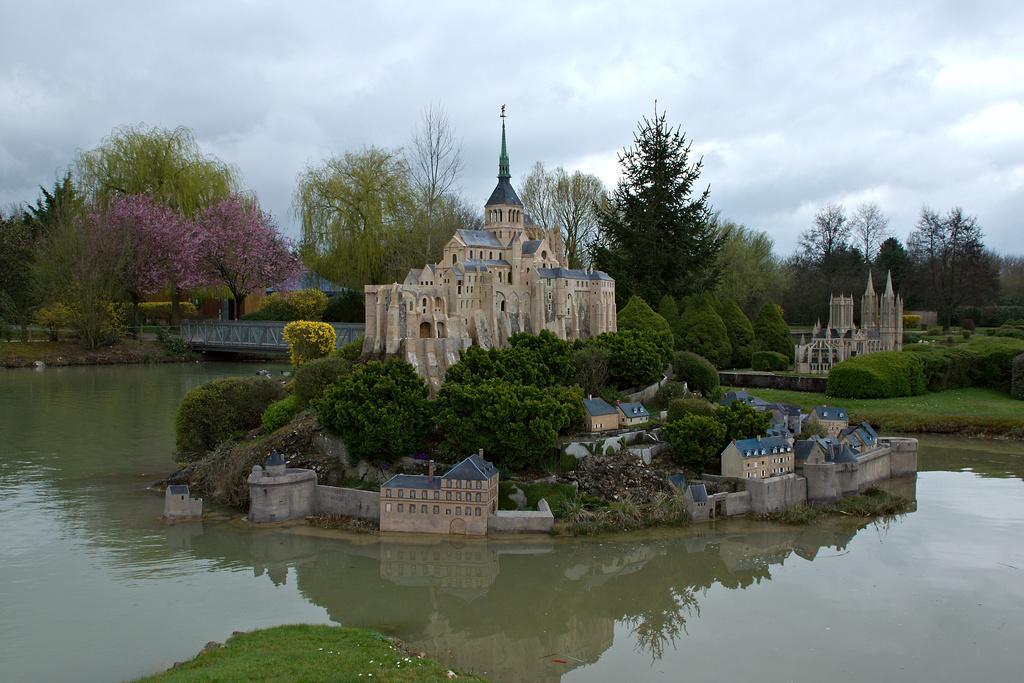Could you give a brief overview of what you see in this image? In this image we can see the building, trees and the wall. Beside the buildings we can see the water. On the water we have the reflection of trees and buildings. In the background, we can see the plants, trees, grass, bridge and a building. At the top we can see the sky. 